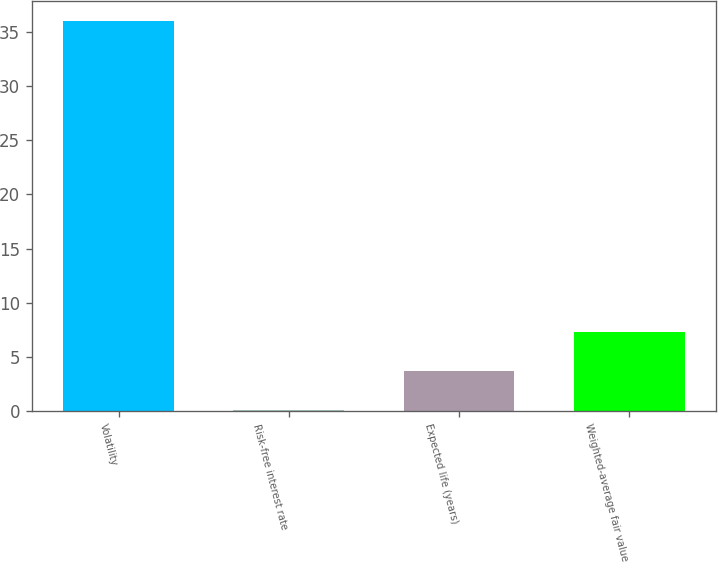Convert chart to OTSL. <chart><loc_0><loc_0><loc_500><loc_500><bar_chart><fcel>Volatility<fcel>Risk-free interest rate<fcel>Expected life (years)<fcel>Weighted-average fair value<nl><fcel>36<fcel>0.1<fcel>3.69<fcel>7.28<nl></chart> 